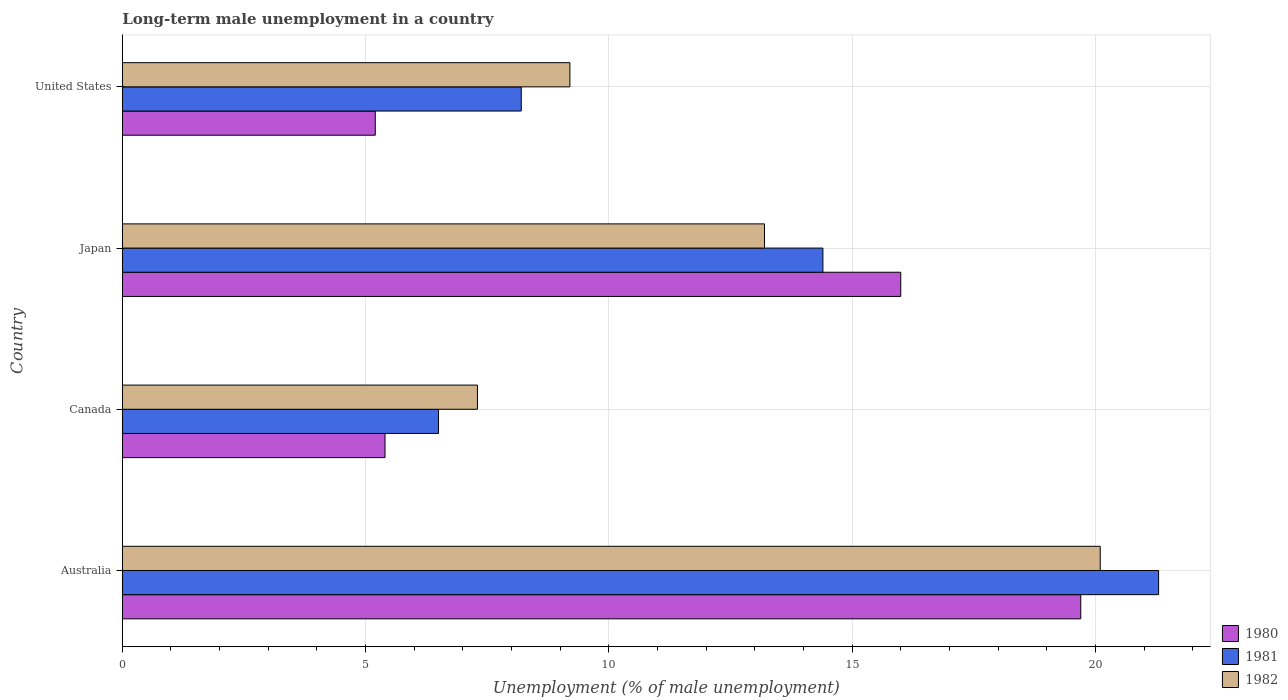How many groups of bars are there?
Make the answer very short. 4. Are the number of bars on each tick of the Y-axis equal?
Give a very brief answer. Yes. How many bars are there on the 2nd tick from the top?
Your answer should be very brief. 3. How many bars are there on the 4th tick from the bottom?
Give a very brief answer. 3. What is the label of the 3rd group of bars from the top?
Your answer should be compact. Canada. In how many cases, is the number of bars for a given country not equal to the number of legend labels?
Provide a succinct answer. 0. What is the percentage of long-term unemployed male population in 1981 in Japan?
Ensure brevity in your answer.  14.4. Across all countries, what is the maximum percentage of long-term unemployed male population in 1980?
Provide a short and direct response. 19.7. Across all countries, what is the minimum percentage of long-term unemployed male population in 1980?
Your response must be concise. 5.2. In which country was the percentage of long-term unemployed male population in 1980 maximum?
Your answer should be compact. Australia. In which country was the percentage of long-term unemployed male population in 1981 minimum?
Provide a short and direct response. Canada. What is the total percentage of long-term unemployed male population in 1980 in the graph?
Offer a terse response. 46.3. What is the difference between the percentage of long-term unemployed male population in 1982 in Australia and that in Japan?
Your answer should be compact. 6.9. What is the difference between the percentage of long-term unemployed male population in 1982 in Canada and the percentage of long-term unemployed male population in 1981 in Australia?
Provide a short and direct response. -14. What is the average percentage of long-term unemployed male population in 1981 per country?
Your answer should be compact. 12.6. What is the difference between the percentage of long-term unemployed male population in 1980 and percentage of long-term unemployed male population in 1981 in Canada?
Give a very brief answer. -1.1. In how many countries, is the percentage of long-term unemployed male population in 1980 greater than 14 %?
Ensure brevity in your answer.  2. What is the ratio of the percentage of long-term unemployed male population in 1981 in Japan to that in United States?
Provide a short and direct response. 1.76. What is the difference between the highest and the second highest percentage of long-term unemployed male population in 1980?
Ensure brevity in your answer.  3.7. What is the difference between the highest and the lowest percentage of long-term unemployed male population in 1981?
Provide a short and direct response. 14.8. In how many countries, is the percentage of long-term unemployed male population in 1981 greater than the average percentage of long-term unemployed male population in 1981 taken over all countries?
Keep it short and to the point. 2. How many bars are there?
Provide a succinct answer. 12. Are all the bars in the graph horizontal?
Offer a terse response. Yes. How many countries are there in the graph?
Give a very brief answer. 4. What is the difference between two consecutive major ticks on the X-axis?
Ensure brevity in your answer.  5. How are the legend labels stacked?
Make the answer very short. Vertical. What is the title of the graph?
Provide a short and direct response. Long-term male unemployment in a country. Does "1990" appear as one of the legend labels in the graph?
Your response must be concise. No. What is the label or title of the X-axis?
Keep it short and to the point. Unemployment (% of male unemployment). What is the Unemployment (% of male unemployment) of 1980 in Australia?
Offer a terse response. 19.7. What is the Unemployment (% of male unemployment) of 1981 in Australia?
Keep it short and to the point. 21.3. What is the Unemployment (% of male unemployment) of 1982 in Australia?
Keep it short and to the point. 20.1. What is the Unemployment (% of male unemployment) in 1980 in Canada?
Make the answer very short. 5.4. What is the Unemployment (% of male unemployment) of 1981 in Canada?
Offer a terse response. 6.5. What is the Unemployment (% of male unemployment) in 1982 in Canada?
Ensure brevity in your answer.  7.3. What is the Unemployment (% of male unemployment) of 1980 in Japan?
Keep it short and to the point. 16. What is the Unemployment (% of male unemployment) of 1981 in Japan?
Offer a very short reply. 14.4. What is the Unemployment (% of male unemployment) in 1982 in Japan?
Ensure brevity in your answer.  13.2. What is the Unemployment (% of male unemployment) in 1980 in United States?
Ensure brevity in your answer.  5.2. What is the Unemployment (% of male unemployment) of 1981 in United States?
Your answer should be compact. 8.2. What is the Unemployment (% of male unemployment) in 1982 in United States?
Keep it short and to the point. 9.2. Across all countries, what is the maximum Unemployment (% of male unemployment) in 1980?
Make the answer very short. 19.7. Across all countries, what is the maximum Unemployment (% of male unemployment) in 1981?
Keep it short and to the point. 21.3. Across all countries, what is the maximum Unemployment (% of male unemployment) in 1982?
Offer a very short reply. 20.1. Across all countries, what is the minimum Unemployment (% of male unemployment) of 1980?
Your answer should be compact. 5.2. Across all countries, what is the minimum Unemployment (% of male unemployment) in 1981?
Offer a terse response. 6.5. Across all countries, what is the minimum Unemployment (% of male unemployment) in 1982?
Your response must be concise. 7.3. What is the total Unemployment (% of male unemployment) in 1980 in the graph?
Your response must be concise. 46.3. What is the total Unemployment (% of male unemployment) of 1981 in the graph?
Keep it short and to the point. 50.4. What is the total Unemployment (% of male unemployment) of 1982 in the graph?
Your answer should be very brief. 49.8. What is the difference between the Unemployment (% of male unemployment) of 1980 in Australia and that in Canada?
Give a very brief answer. 14.3. What is the difference between the Unemployment (% of male unemployment) in 1981 in Australia and that in Canada?
Provide a short and direct response. 14.8. What is the difference between the Unemployment (% of male unemployment) of 1982 in Australia and that in Canada?
Ensure brevity in your answer.  12.8. What is the difference between the Unemployment (% of male unemployment) of 1981 in Australia and that in Japan?
Your answer should be very brief. 6.9. What is the difference between the Unemployment (% of male unemployment) of 1980 in Australia and that in United States?
Provide a short and direct response. 14.5. What is the difference between the Unemployment (% of male unemployment) of 1981 in Canada and that in Japan?
Make the answer very short. -7.9. What is the difference between the Unemployment (% of male unemployment) in 1982 in Canada and that in Japan?
Your response must be concise. -5.9. What is the difference between the Unemployment (% of male unemployment) of 1982 in Canada and that in United States?
Provide a short and direct response. -1.9. What is the difference between the Unemployment (% of male unemployment) of 1980 in Japan and that in United States?
Your answer should be compact. 10.8. What is the difference between the Unemployment (% of male unemployment) of 1980 in Australia and the Unemployment (% of male unemployment) of 1981 in Canada?
Ensure brevity in your answer.  13.2. What is the difference between the Unemployment (% of male unemployment) in 1980 in Australia and the Unemployment (% of male unemployment) in 1981 in United States?
Your answer should be very brief. 11.5. What is the difference between the Unemployment (% of male unemployment) in 1980 in Australia and the Unemployment (% of male unemployment) in 1982 in United States?
Offer a terse response. 10.5. What is the difference between the Unemployment (% of male unemployment) in 1981 in Australia and the Unemployment (% of male unemployment) in 1982 in United States?
Make the answer very short. 12.1. What is the difference between the Unemployment (% of male unemployment) in 1980 in Canada and the Unemployment (% of male unemployment) in 1982 in United States?
Your answer should be very brief. -3.8. What is the difference between the Unemployment (% of male unemployment) of 1980 in Japan and the Unemployment (% of male unemployment) of 1981 in United States?
Offer a very short reply. 7.8. What is the difference between the Unemployment (% of male unemployment) in 1980 in Japan and the Unemployment (% of male unemployment) in 1982 in United States?
Give a very brief answer. 6.8. What is the average Unemployment (% of male unemployment) of 1980 per country?
Give a very brief answer. 11.57. What is the average Unemployment (% of male unemployment) of 1982 per country?
Your response must be concise. 12.45. What is the difference between the Unemployment (% of male unemployment) of 1980 and Unemployment (% of male unemployment) of 1982 in Australia?
Offer a terse response. -0.4. What is the difference between the Unemployment (% of male unemployment) in 1981 and Unemployment (% of male unemployment) in 1982 in Australia?
Your response must be concise. 1.2. What is the difference between the Unemployment (% of male unemployment) in 1980 and Unemployment (% of male unemployment) in 1981 in Canada?
Ensure brevity in your answer.  -1.1. What is the difference between the Unemployment (% of male unemployment) in 1980 and Unemployment (% of male unemployment) in 1981 in Japan?
Give a very brief answer. 1.6. What is the difference between the Unemployment (% of male unemployment) of 1981 and Unemployment (% of male unemployment) of 1982 in Japan?
Your response must be concise. 1.2. What is the difference between the Unemployment (% of male unemployment) of 1980 and Unemployment (% of male unemployment) of 1981 in United States?
Offer a very short reply. -3. What is the difference between the Unemployment (% of male unemployment) of 1980 and Unemployment (% of male unemployment) of 1982 in United States?
Your response must be concise. -4. What is the difference between the Unemployment (% of male unemployment) in 1981 and Unemployment (% of male unemployment) in 1982 in United States?
Offer a terse response. -1. What is the ratio of the Unemployment (% of male unemployment) in 1980 in Australia to that in Canada?
Your answer should be compact. 3.65. What is the ratio of the Unemployment (% of male unemployment) of 1981 in Australia to that in Canada?
Provide a short and direct response. 3.28. What is the ratio of the Unemployment (% of male unemployment) of 1982 in Australia to that in Canada?
Your answer should be very brief. 2.75. What is the ratio of the Unemployment (% of male unemployment) of 1980 in Australia to that in Japan?
Give a very brief answer. 1.23. What is the ratio of the Unemployment (% of male unemployment) of 1981 in Australia to that in Japan?
Provide a short and direct response. 1.48. What is the ratio of the Unemployment (% of male unemployment) of 1982 in Australia to that in Japan?
Make the answer very short. 1.52. What is the ratio of the Unemployment (% of male unemployment) in 1980 in Australia to that in United States?
Make the answer very short. 3.79. What is the ratio of the Unemployment (% of male unemployment) of 1981 in Australia to that in United States?
Offer a very short reply. 2.6. What is the ratio of the Unemployment (% of male unemployment) of 1982 in Australia to that in United States?
Your answer should be compact. 2.18. What is the ratio of the Unemployment (% of male unemployment) in 1980 in Canada to that in Japan?
Give a very brief answer. 0.34. What is the ratio of the Unemployment (% of male unemployment) in 1981 in Canada to that in Japan?
Your response must be concise. 0.45. What is the ratio of the Unemployment (% of male unemployment) of 1982 in Canada to that in Japan?
Keep it short and to the point. 0.55. What is the ratio of the Unemployment (% of male unemployment) in 1980 in Canada to that in United States?
Ensure brevity in your answer.  1.04. What is the ratio of the Unemployment (% of male unemployment) of 1981 in Canada to that in United States?
Keep it short and to the point. 0.79. What is the ratio of the Unemployment (% of male unemployment) of 1982 in Canada to that in United States?
Make the answer very short. 0.79. What is the ratio of the Unemployment (% of male unemployment) of 1980 in Japan to that in United States?
Provide a short and direct response. 3.08. What is the ratio of the Unemployment (% of male unemployment) in 1981 in Japan to that in United States?
Keep it short and to the point. 1.76. What is the ratio of the Unemployment (% of male unemployment) of 1982 in Japan to that in United States?
Your response must be concise. 1.43. What is the difference between the highest and the lowest Unemployment (% of male unemployment) in 1981?
Your answer should be compact. 14.8. 